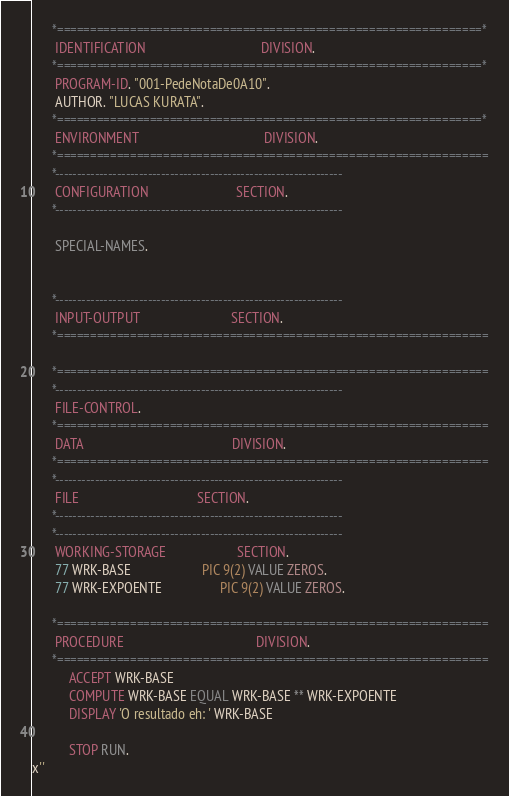Convert code to text. <code><loc_0><loc_0><loc_500><loc_500><_COBOL_>      *================================================================*
       IDENTIFICATION                                  DIVISION.
      *================================================================*
       PROGRAM-ID. "001-PedeNotaDe0A10".
       AUTHOR. "LUCAS KURATA".
      *================================================================*
       ENVIRONMENT                                     DIVISION.
      *=================================================================
      *-----------------------------------------------------------------
       CONFIGURATION                          SECTION.
      *-----------------------------------------------------------------

       SPECIAL-NAMES.


      *-----------------------------------------------------------------
       INPUT-OUTPUT                           SECTION.
      *=================================================================

      *=================================================================
      *-----------------------------------------------------------------
       FILE-CONTROL.
      *=================================================================
       DATA                                            DIVISION.
      *=================================================================
      *-----------------------------------------------------------------
       FILE                                   SECTION.
      *-----------------------------------------------------------------
      *-----------------------------------------------------------------
       WORKING-STORAGE                     SECTION.
       77 WRK-BASE                     PIC 9(2) VALUE ZEROS.
       77 WRK-EXPOENTE                 PIC 9(2) VALUE ZEROS.

      *=================================================================
       PROCEDURE                                       DIVISION.
      *=================================================================
           ACCEPT WRK-BASE
           COMPUTE WRK-BASE EQUAL WRK-BASE ** WRK-EXPOENTE
           DISPLAY 'O resultado eh: ' WRK-BASE

           STOP RUN.
x''
</code> 